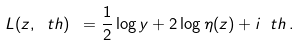Convert formula to latex. <formula><loc_0><loc_0><loc_500><loc_500>L ( z , \ t h ) \ = \frac { 1 } { 2 } \log y + 2 \log \eta ( z ) + i \ t h \, .</formula> 